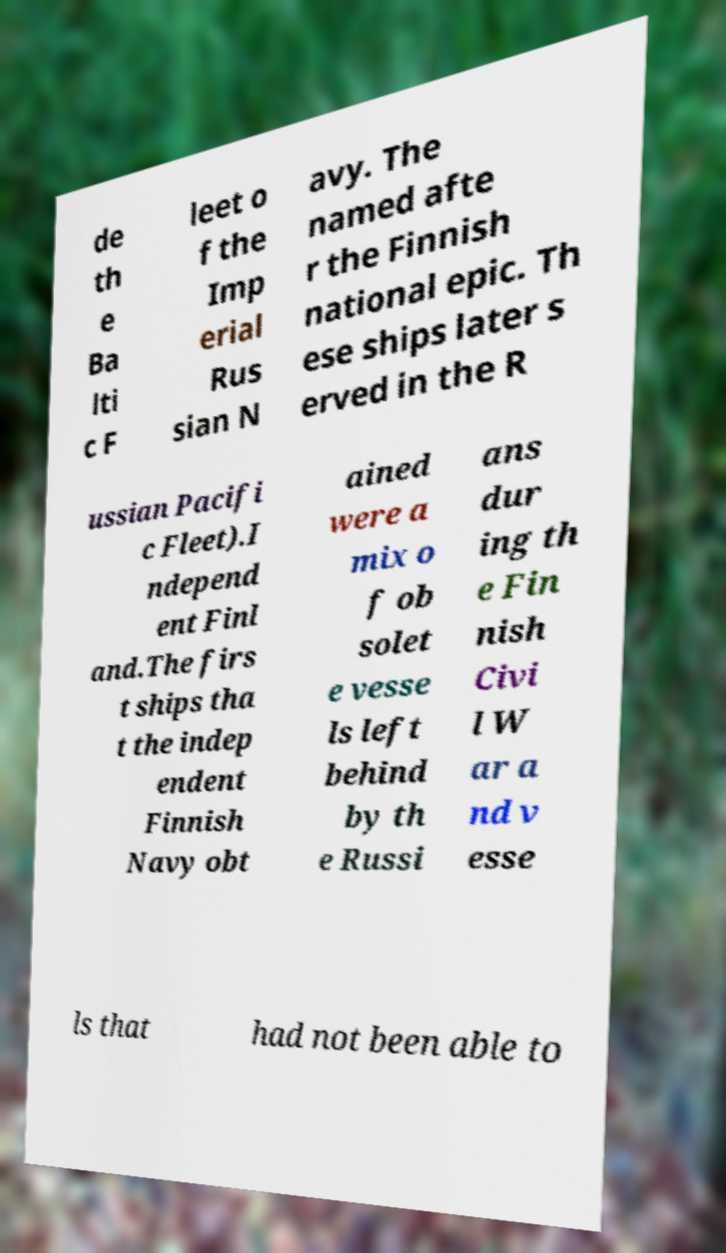I need the written content from this picture converted into text. Can you do that? de th e Ba lti c F leet o f the Imp erial Rus sian N avy. The named afte r the Finnish national epic. Th ese ships later s erved in the R ussian Pacifi c Fleet).I ndepend ent Finl and.The firs t ships tha t the indep endent Finnish Navy obt ained were a mix o f ob solet e vesse ls left behind by th e Russi ans dur ing th e Fin nish Civi l W ar a nd v esse ls that had not been able to 